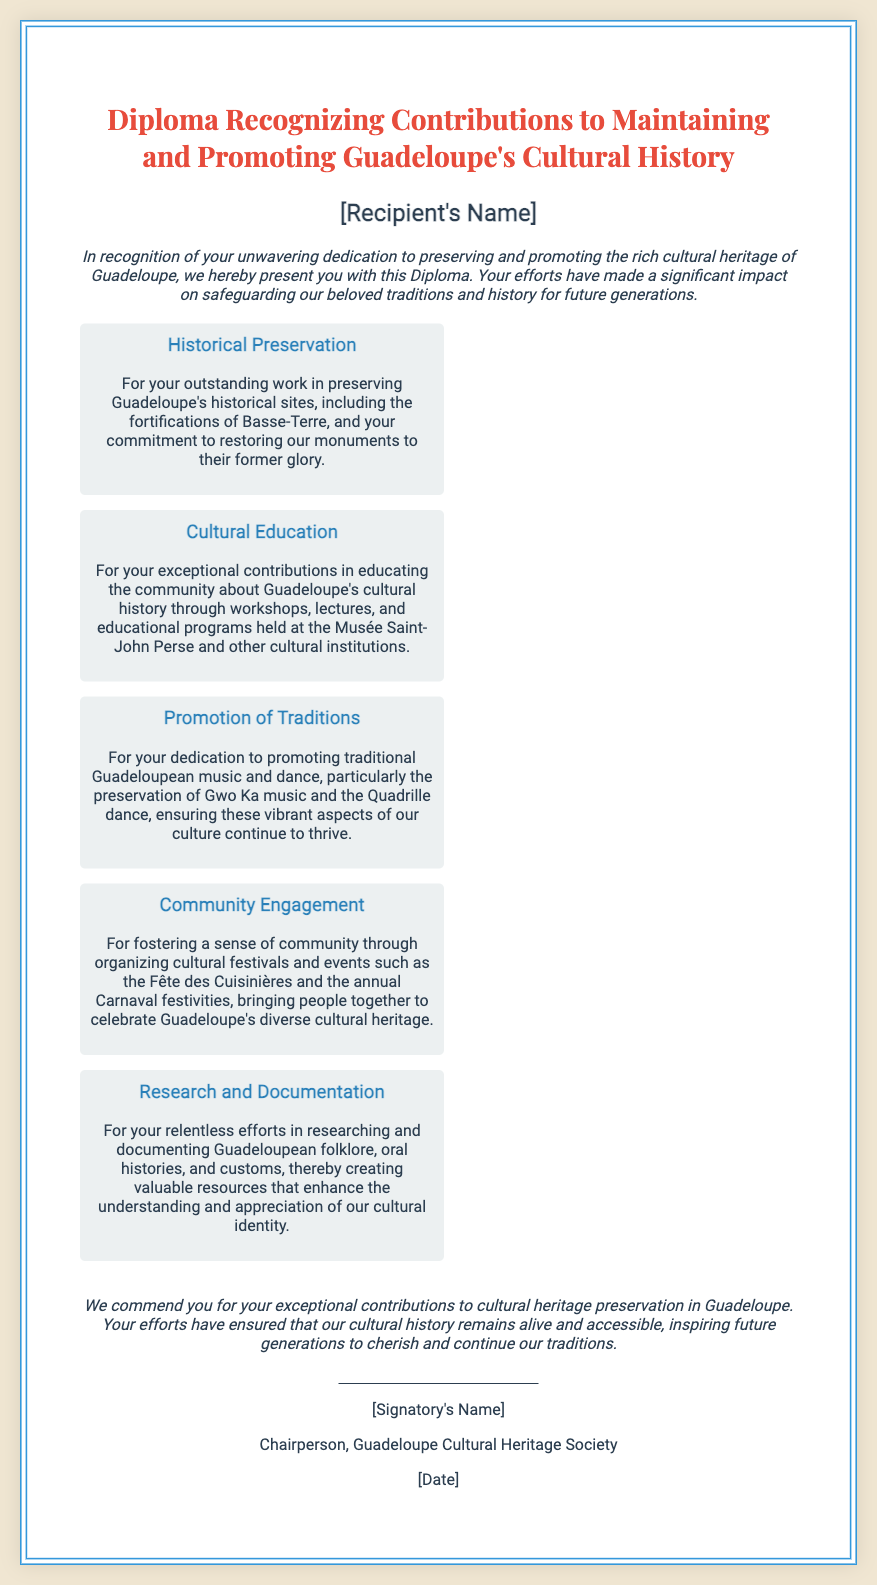What is the title of the diploma? The title of the diploma is specified at the top of the document in a prominent way.
Answer: Diploma Recognizing Contributions to Maintaining and Promoting Guadeloupe's Cultural History Who is being recognized with this diploma? The recipient's name is mentioned prominently under the title, indicating who is being honored.
Answer: [Recipient's Name] What type of work is acknowledged under Historical Preservation? The diploma specifically mentions the preservation of historical sites as part of this section.
Answer: Preserving Guadeloupe's historical sites Which cultural institution is highlighted for education contributions? The document states that educational contributions were made through programs held at a particular cultural institution.
Answer: Musée Saint-John Perse What traditional music is specifically mentioned in the diploma? This aspect mentions a particular traditional music form that is significant to Guadeloupean culture.
Answer: Gwo Ka music What community event is named in the Community Engagement section? The document lists a specific festival that exemplifies community engagement efforts.
Answer: Fête des Cuisinières How has the diploma recognized contributions to research? The diploma mentions efforts regarding the documentation of specific cultural elements.
Answer: Researching and documenting folklore Who is the signatory of the diploma? The signatory's position is noted at the bottom, indicating the authority behind the diploma.
Answer: Chairperson, Guadeloupe Cultural Heritage Society 